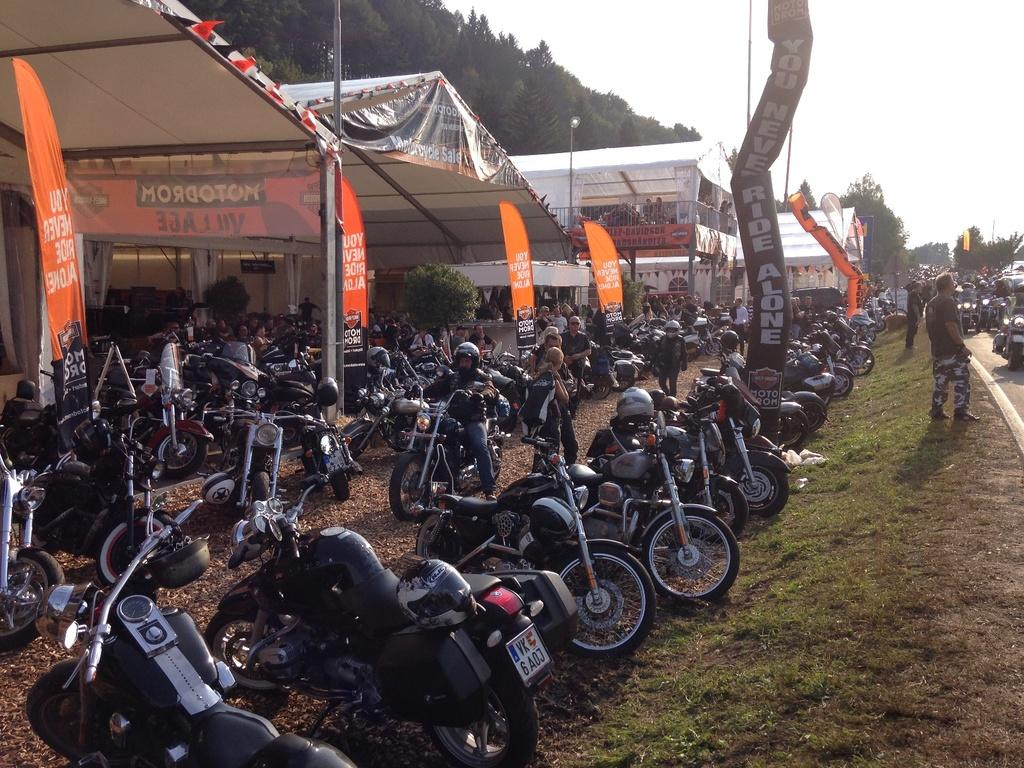What type of vehicles are present in the image? There are motorbikes in the image. Who or what else can be seen in the image? There are people and tents in the image. Are there any signs or markers in the image? Yes, there are banners in the image. What can be seen in the background of the image? There are trees in the background of the image. Where is the cellar located in the image? There is no cellar present in the image. What type of rail is visible in the image? There is no rail present in the image. 